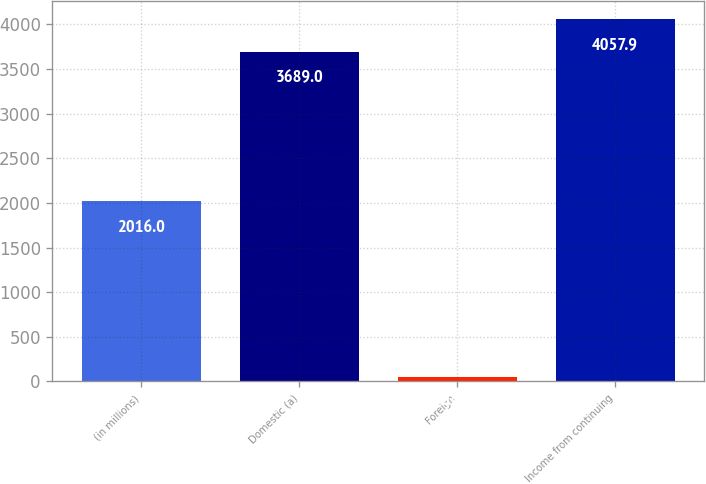Convert chart to OTSL. <chart><loc_0><loc_0><loc_500><loc_500><bar_chart><fcel>(in millions)<fcel>Domestic (a)<fcel>Foreign<fcel>Income from continuing<nl><fcel>2016<fcel>3689<fcel>45<fcel>4057.9<nl></chart> 